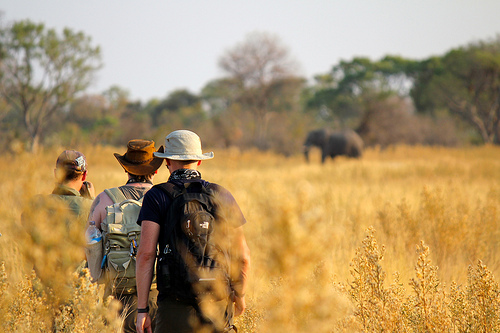What is the image showing? The image shows a plain. 